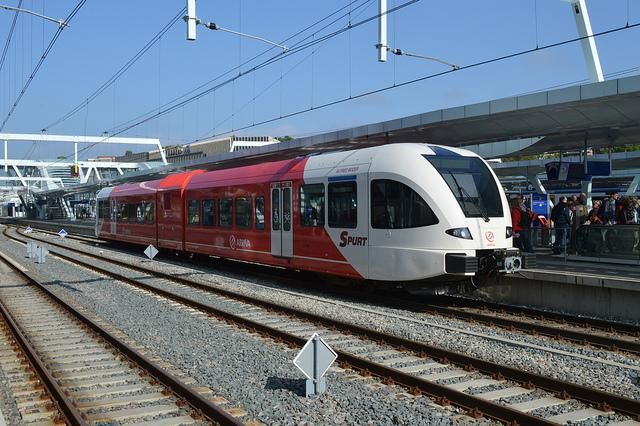What type power does this train use? electric 